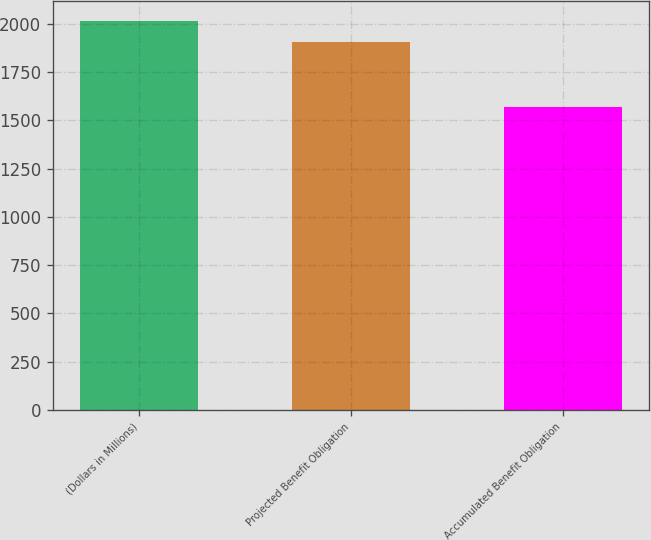Convert chart. <chart><loc_0><loc_0><loc_500><loc_500><bar_chart><fcel>(Dollars in Millions)<fcel>Projected Benefit Obligation<fcel>Accumulated Benefit Obligation<nl><fcel>2016<fcel>1905<fcel>1568<nl></chart> 